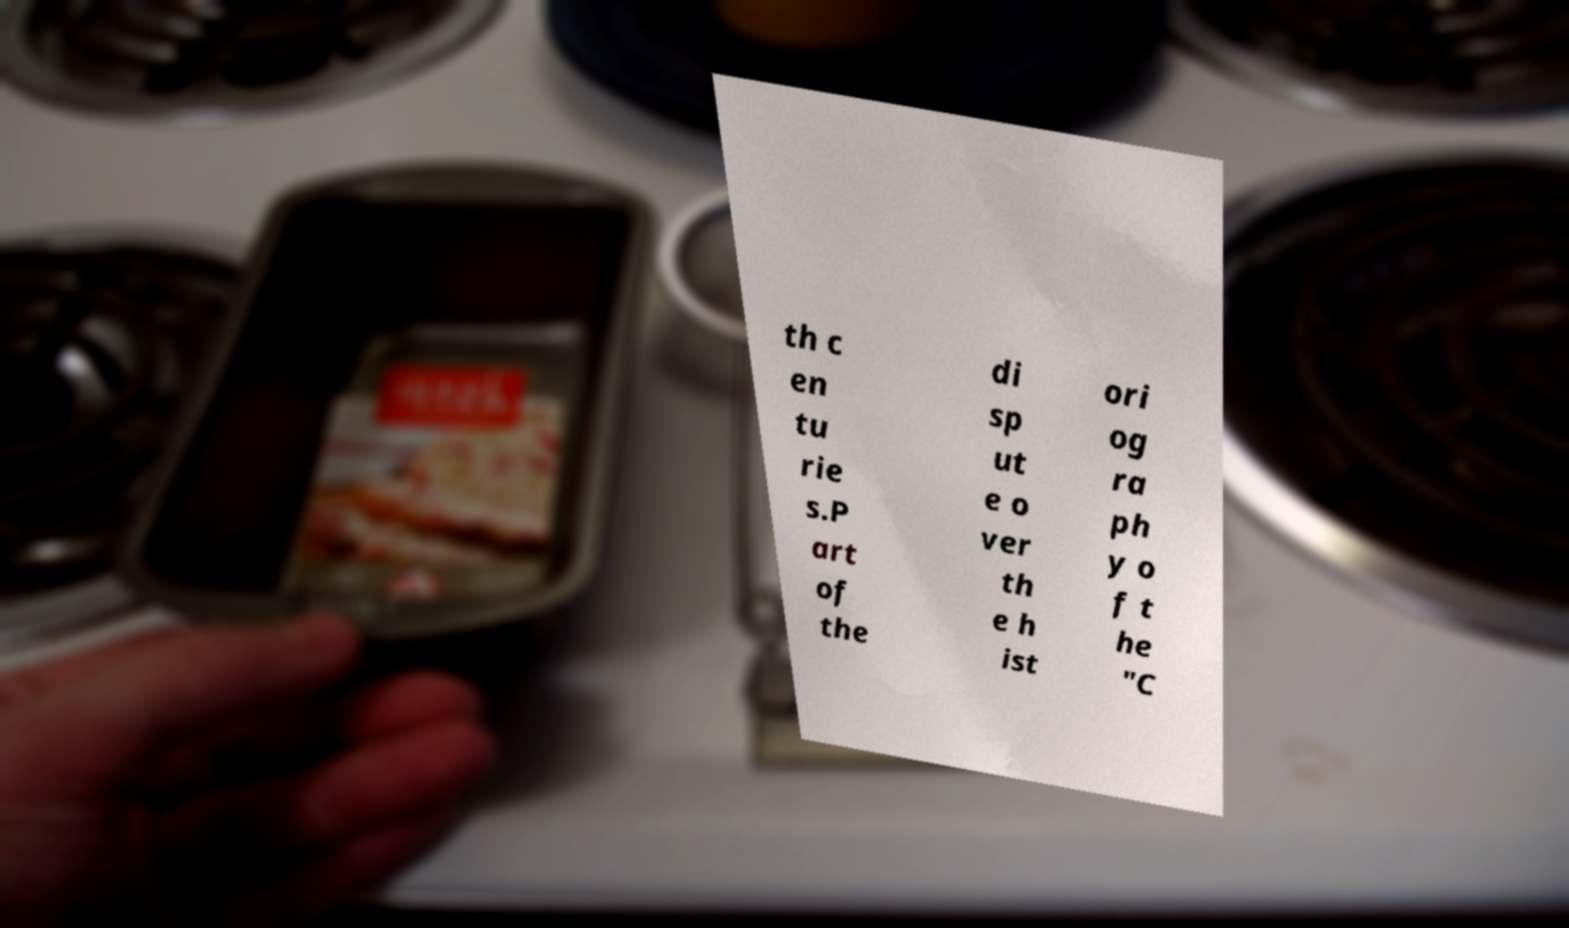For documentation purposes, I need the text within this image transcribed. Could you provide that? th c en tu rie s.P art of the di sp ut e o ver th e h ist ori og ra ph y o f t he "C 